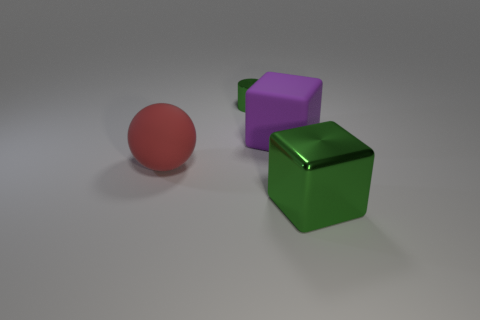What can you infer about the time of day or setting of this scene? The scene is likely an indoor setup with controlled lighting rather than a natural setting, as indicated by the softness of the shadows and the neutral background, making it difficult to infer a specific time of day. 